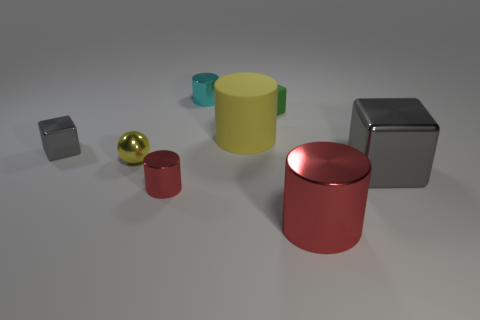Subtract all big yellow matte cylinders. How many cylinders are left? 3 Subtract 2 cylinders. How many cylinders are left? 2 Add 1 green matte cubes. How many objects exist? 9 Subtract all spheres. How many objects are left? 7 Subtract all gray blocks. How many blocks are left? 1 Subtract all small brown metal cylinders. Subtract all tiny gray metal things. How many objects are left? 7 Add 1 small cyan metallic cylinders. How many small cyan metallic cylinders are left? 2 Add 3 small gray things. How many small gray things exist? 4 Subtract 0 green spheres. How many objects are left? 8 Subtract all green balls. Subtract all cyan blocks. How many balls are left? 1 